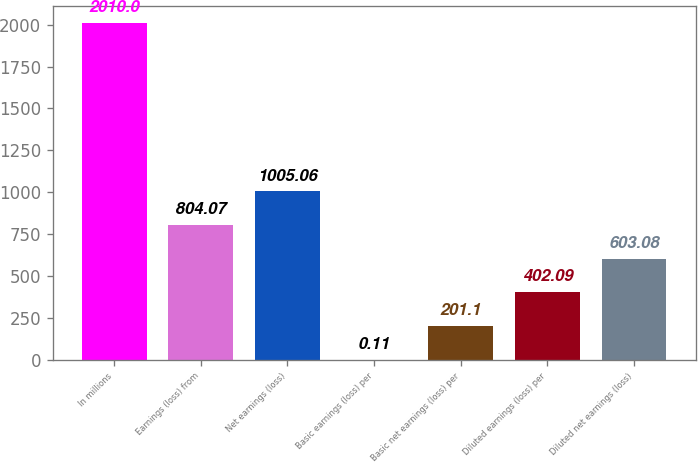<chart> <loc_0><loc_0><loc_500><loc_500><bar_chart><fcel>In millions<fcel>Earnings (loss) from<fcel>Net earnings (loss)<fcel>Basic earnings (loss) per<fcel>Basic net earnings (loss) per<fcel>Diluted earnings (loss) per<fcel>Diluted net earnings (loss)<nl><fcel>2010<fcel>804.07<fcel>1005.06<fcel>0.11<fcel>201.1<fcel>402.09<fcel>603.08<nl></chart> 